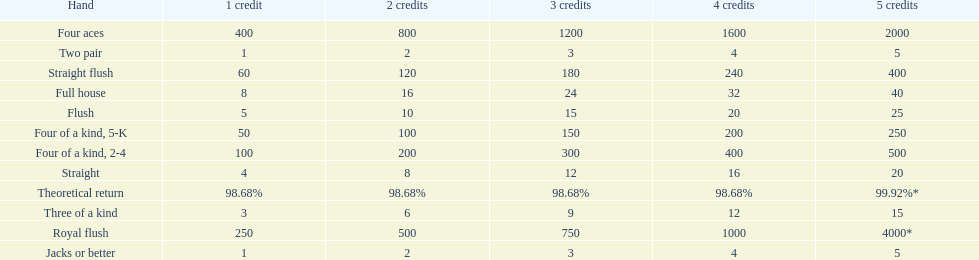What's the best type of four of a kind to win? Four of a kind, 2-4. 